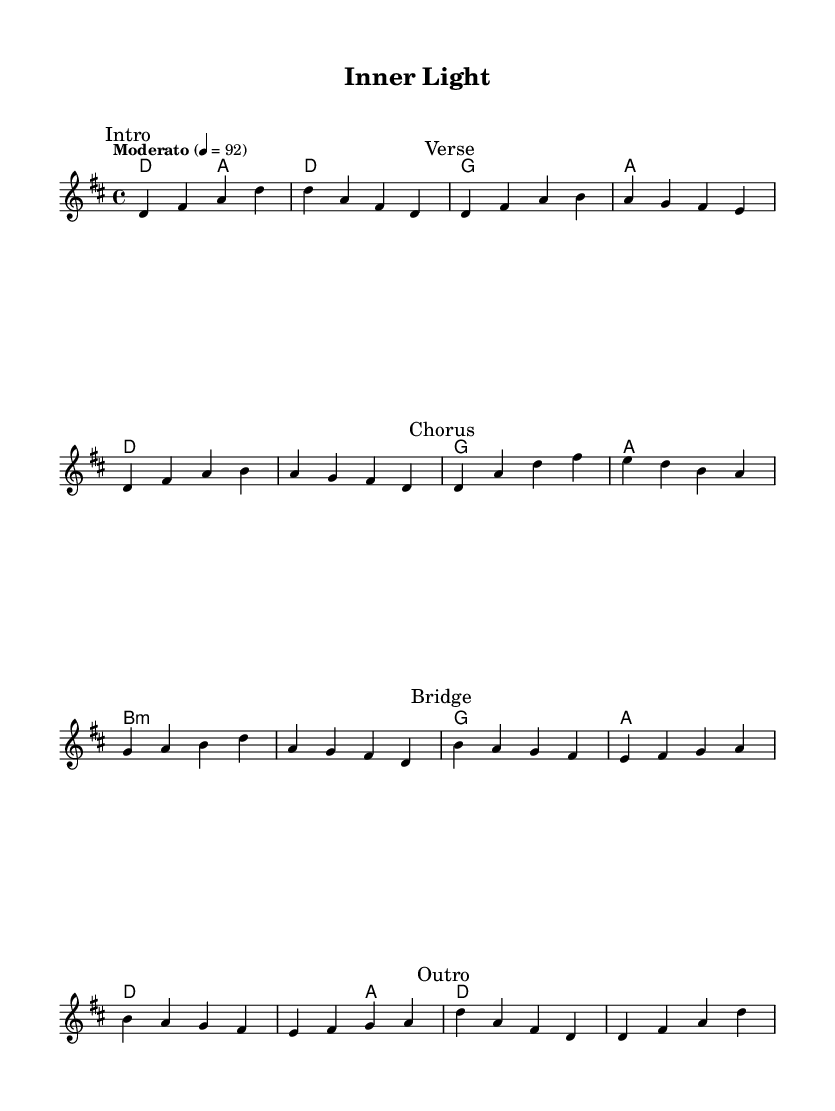What is the key signature of this music? The key signature is D major, which consists of two sharps (F# and C#). This can be determined by looking at the key indicated at the beginning of the score, which is marked as "d" in the global settings.
Answer: D major What is the time signature of this music? The time signature is 4/4, indicating that there are four beats in each measure and a quarter note receives one beat. This is specified at the start of the piece in the global settings.
Answer: 4/4 What is the tempo marking for this piece? The tempo marking is "Moderato" at a metronome marking of 92 beats per minute. This can be seen in the global settings section of the code.
Answer: Moderato, 92 How many sections are there in the music? The music is divided into five sections: Intro, Verse, Chorus, Bridge, and Outro. This is indicated in the structure of the code where each section is explicitly marked.
Answer: Five Which chord is repeated in the Verse section? The chord that appears multiple times in the Verse section is D major. It first appears in the second measure of the Verse and is a consistent part of its harmonic progression.
Answer: D What is the last chord played in the Outro? The last chord in the Outro is D major, which can be found in the final measure of the score. This is indicated in the harmonies section where the values align with theOutro.
Answer: D Which section contains a Bridge? The section labeled "Bridge" contains the bridge. This section is specifically marked in the sheet music, making it clear where the bridge occurs in the overall structure of the piece.
Answer: Bridge 